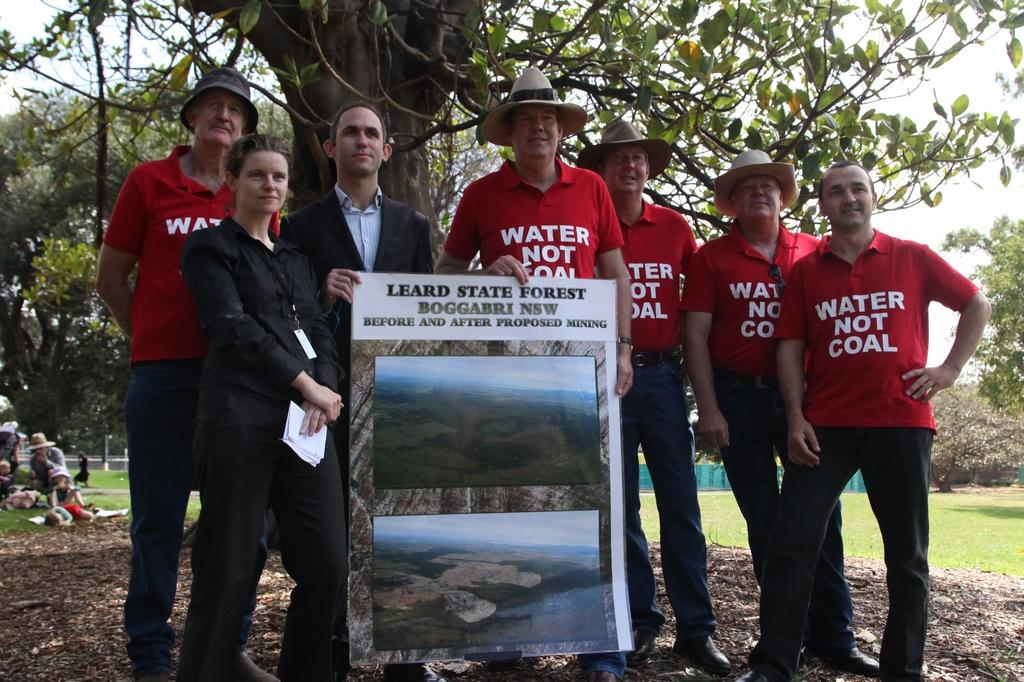What are the people in the image doing? People are standing in the image. What are they holding? They are holding a banner. What can be observed about the clothing of some people in the image? Some people are wearing red t-shirts. Are there any accessories visible on the people in the image? Yes, some people are wearing hats. What can be seen in the distance behind the people? There are trees visible in the background. Reasoning: Let's image, which is the people standing in the image. Then, we focus on the details of the people, such as their clothing and accessories. We also mention the background to give a sense of the setting. Absurd Question/Answer: How many toes can be seen on the people in the image? There are no visible toes on the people in the image. --- Facts: 1. There is a car in the image. 2. The car is red. 3. The car has four wheels. 4. There are people sitting inside the car. 5. The car has a sunroof. Absurd Topics: moon Conversation: What is the main subject in the image? There is a car in the image. What color is the car? The car is red. How many wheels does the car have? The car has four wheels. What can be observed about the people inside the car? There are people sitting inside the car. What additional feature does the car have? The car has a sunroof. Can you see the moon in the image? There is no moon visible in the image. 